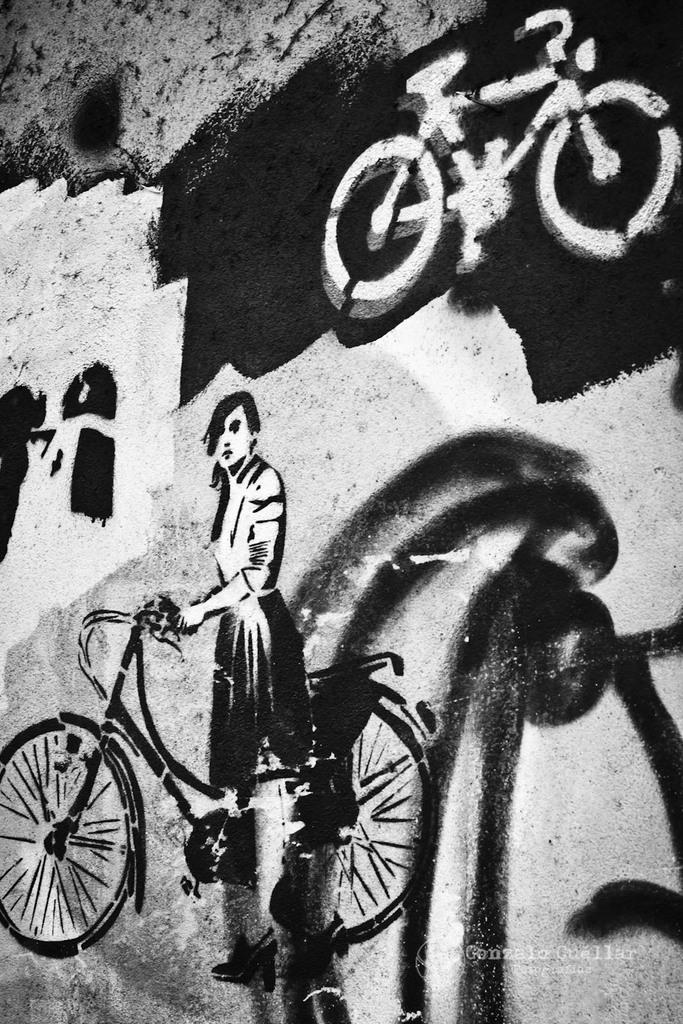What is on the wall in the image? There is a painting on the wall in the image. What is depicted in the painting? The painting depicts two bicycles and a woman. What is the color scheme of the image? The image is black and white. How does the woman in the painting sort the engine parts? There is no engine or engine parts present in the painting; it features two bicycles and a woman. 